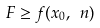<formula> <loc_0><loc_0><loc_500><loc_500>F \geq f ( x _ { 0 } , \ n )</formula> 